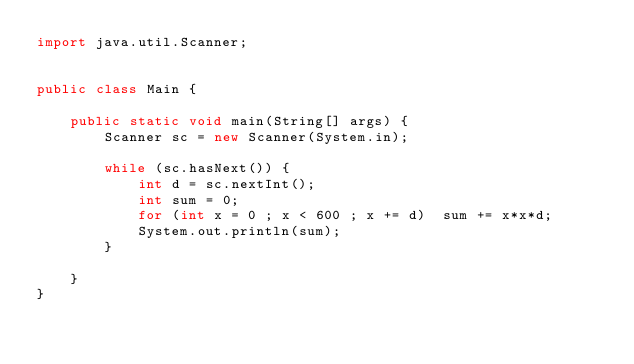Convert code to text. <code><loc_0><loc_0><loc_500><loc_500><_Java_>import java.util.Scanner;


public class Main {

	public static void main(String[] args) {
		Scanner sc = new Scanner(System.in);

		while (sc.hasNext()) {
			int d = sc.nextInt();
			int sum = 0;
			for (int x = 0 ; x < 600 ; x += d)  sum += x*x*d;
			System.out.println(sum);
		}

	}
}</code> 